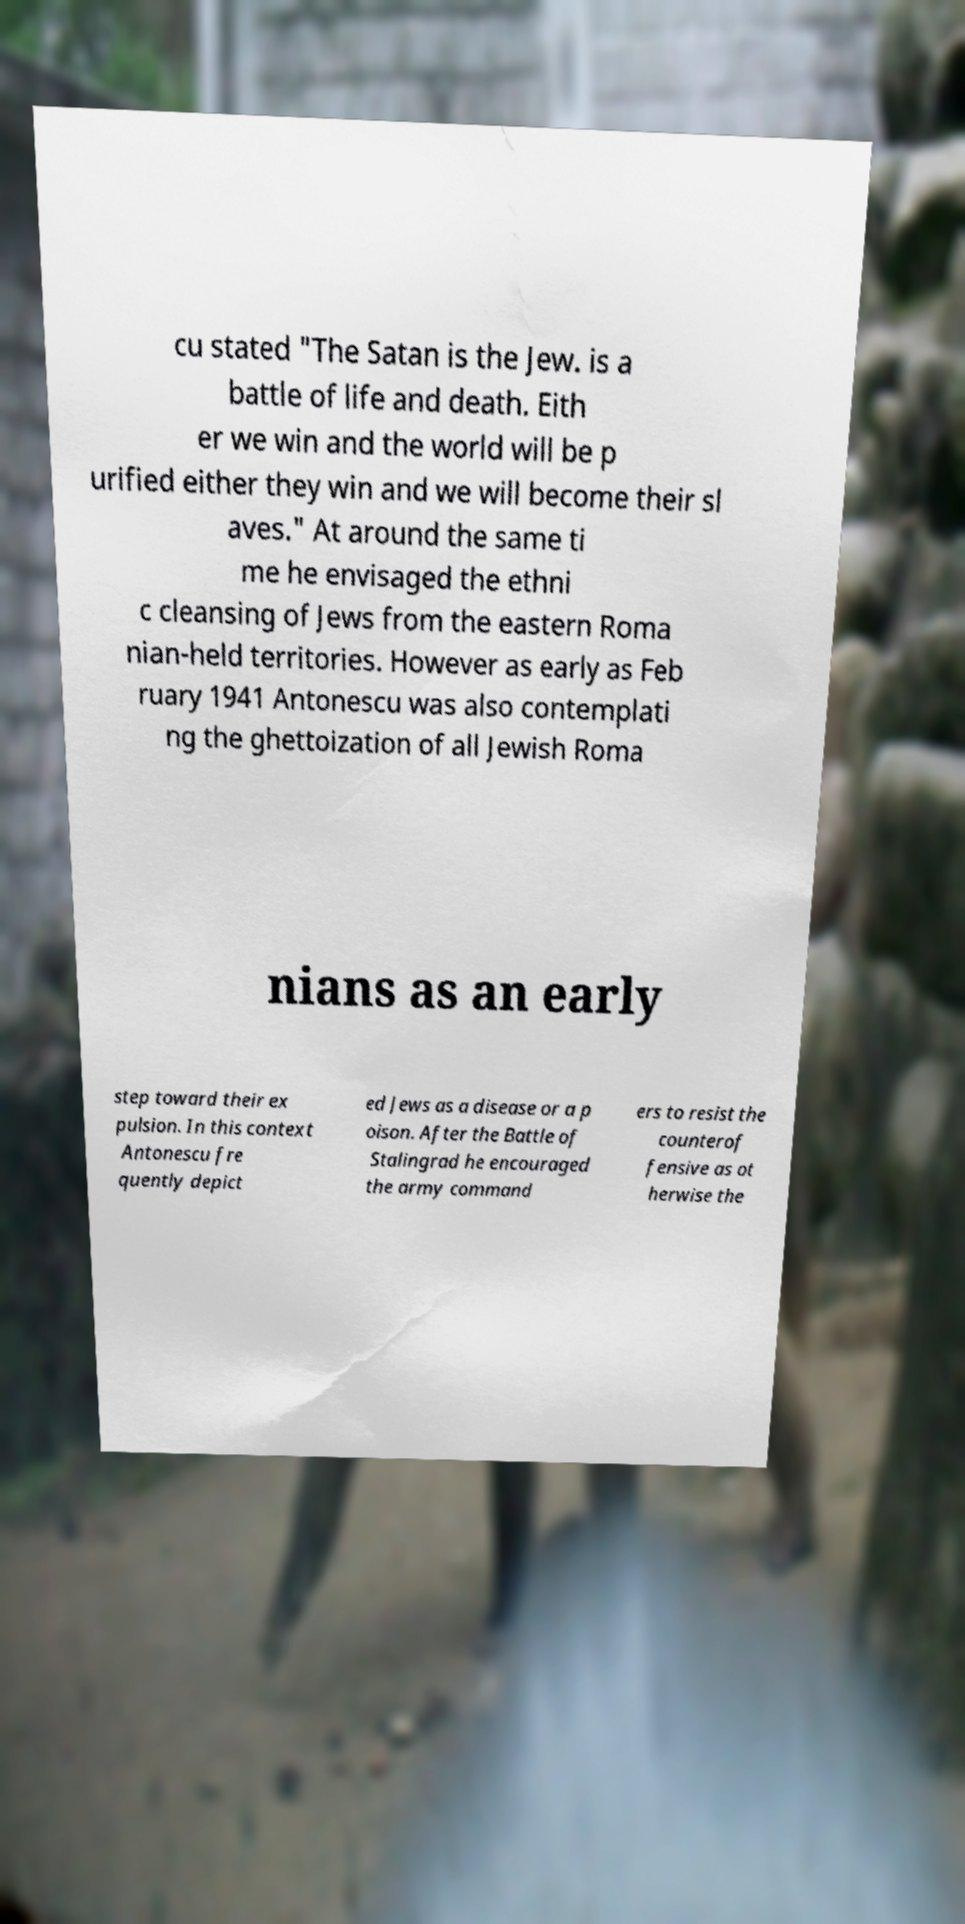Please identify and transcribe the text found in this image. cu stated "The Satan is the Jew. is a battle of life and death. Eith er we win and the world will be p urified either they win and we will become their sl aves." At around the same ti me he envisaged the ethni c cleansing of Jews from the eastern Roma nian-held territories. However as early as Feb ruary 1941 Antonescu was also contemplati ng the ghettoization of all Jewish Roma nians as an early step toward their ex pulsion. In this context Antonescu fre quently depict ed Jews as a disease or a p oison. After the Battle of Stalingrad he encouraged the army command ers to resist the counterof fensive as ot herwise the 